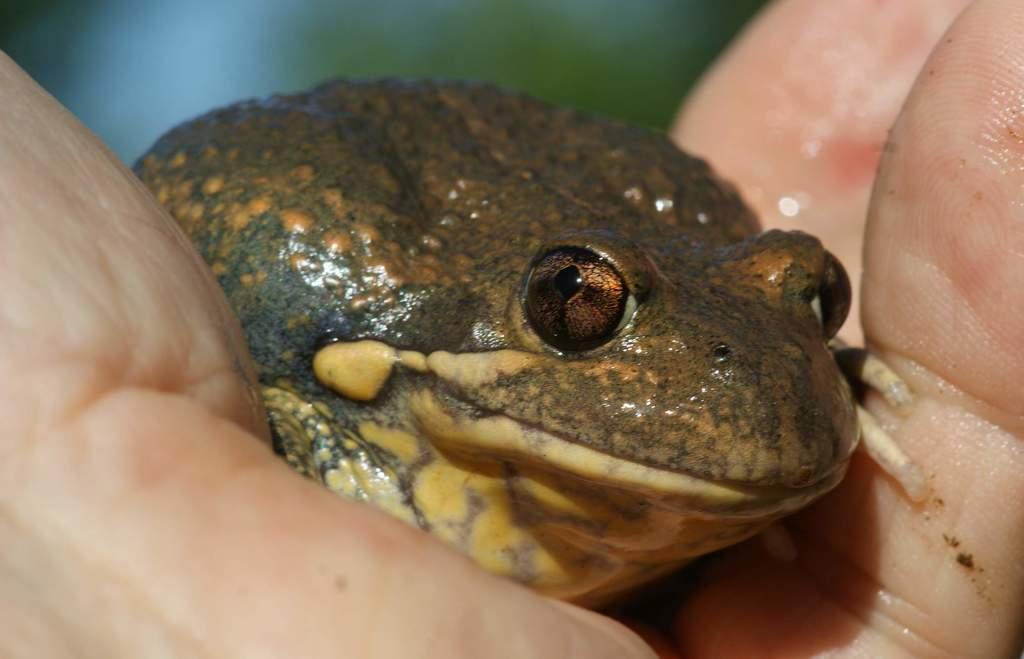What is the main subject in the center of the image? There is a frog in the center of the image. How is the frog being held in the image? The frog is being held by human hands. What type of snakes can be seen slithering around the frog in the image? There are no snakes present in the image; it only features a frog being held by human hands. What star is shining brightly above the frog in the image? The image does not show a star or any celestial objects; it is focused on the frog and human hands. 